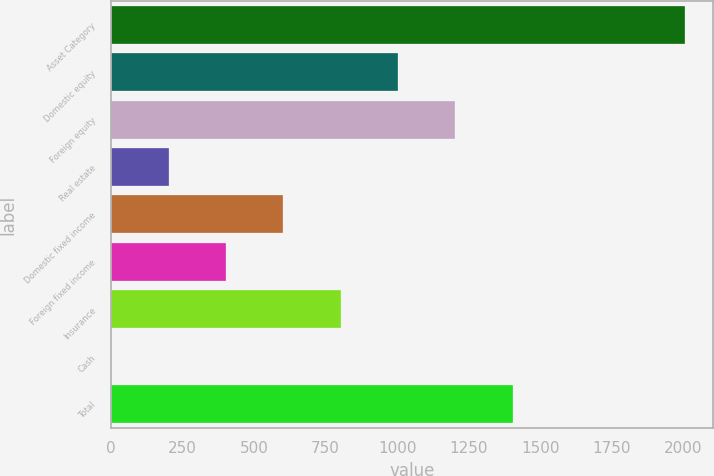<chart> <loc_0><loc_0><loc_500><loc_500><bar_chart><fcel>Asset Category<fcel>Domestic equity<fcel>Foreign equity<fcel>Real estate<fcel>Domestic fixed income<fcel>Foreign fixed income<fcel>Insurance<fcel>Cash<fcel>Total<nl><fcel>2005<fcel>1003<fcel>1203.4<fcel>201.4<fcel>602.2<fcel>401.8<fcel>802.6<fcel>1<fcel>1403.8<nl></chart> 